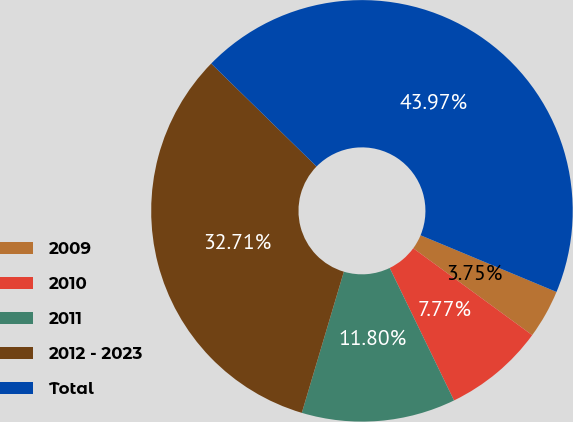Convert chart. <chart><loc_0><loc_0><loc_500><loc_500><pie_chart><fcel>2009<fcel>2010<fcel>2011<fcel>2012 - 2023<fcel>Total<nl><fcel>3.75%<fcel>7.77%<fcel>11.8%<fcel>32.71%<fcel>43.97%<nl></chart> 